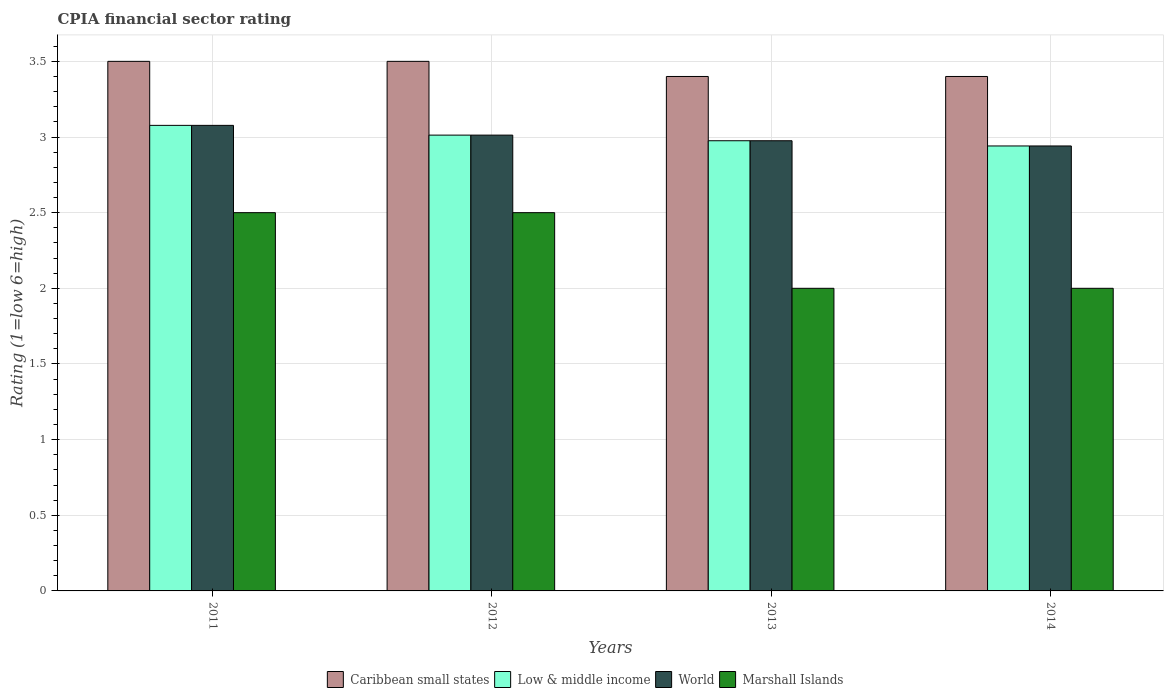How many groups of bars are there?
Offer a terse response. 4. Are the number of bars on each tick of the X-axis equal?
Provide a succinct answer. Yes. What is the label of the 3rd group of bars from the left?
Your response must be concise. 2013. In how many cases, is the number of bars for a given year not equal to the number of legend labels?
Your response must be concise. 0. Across all years, what is the maximum CPIA rating in Marshall Islands?
Your answer should be compact. 2.5. In which year was the CPIA rating in Low & middle income maximum?
Provide a succinct answer. 2011. What is the total CPIA rating in Caribbean small states in the graph?
Your answer should be very brief. 13.8. What is the difference between the CPIA rating in World in 2011 and that in 2014?
Keep it short and to the point. 0.14. What is the difference between the CPIA rating in Low & middle income in 2012 and the CPIA rating in World in 2013?
Your answer should be very brief. 0.04. What is the average CPIA rating in Marshall Islands per year?
Offer a terse response. 2.25. In the year 2011, what is the difference between the CPIA rating in Caribbean small states and CPIA rating in World?
Offer a very short reply. 0.42. What is the ratio of the CPIA rating in Low & middle income in 2012 to that in 2013?
Give a very brief answer. 1.01. Is the difference between the CPIA rating in Caribbean small states in 2011 and 2013 greater than the difference between the CPIA rating in World in 2011 and 2013?
Keep it short and to the point. No. What is the difference between the highest and the lowest CPIA rating in World?
Provide a short and direct response. 0.14. Is the sum of the CPIA rating in Caribbean small states in 2013 and 2014 greater than the maximum CPIA rating in World across all years?
Your response must be concise. Yes. What does the 4th bar from the left in 2014 represents?
Keep it short and to the point. Marshall Islands. How many bars are there?
Keep it short and to the point. 16. Are all the bars in the graph horizontal?
Give a very brief answer. No. How many years are there in the graph?
Offer a very short reply. 4. What is the difference between two consecutive major ticks on the Y-axis?
Keep it short and to the point. 0.5. Are the values on the major ticks of Y-axis written in scientific E-notation?
Ensure brevity in your answer.  No. Does the graph contain any zero values?
Your answer should be very brief. No. Does the graph contain grids?
Provide a short and direct response. Yes. Where does the legend appear in the graph?
Provide a short and direct response. Bottom center. What is the title of the graph?
Your answer should be very brief. CPIA financial sector rating. What is the label or title of the X-axis?
Your answer should be very brief. Years. What is the Rating (1=low 6=high) in Caribbean small states in 2011?
Make the answer very short. 3.5. What is the Rating (1=low 6=high) in Low & middle income in 2011?
Offer a terse response. 3.08. What is the Rating (1=low 6=high) in World in 2011?
Provide a succinct answer. 3.08. What is the Rating (1=low 6=high) of Caribbean small states in 2012?
Keep it short and to the point. 3.5. What is the Rating (1=low 6=high) of Low & middle income in 2012?
Provide a succinct answer. 3.01. What is the Rating (1=low 6=high) in World in 2012?
Provide a short and direct response. 3.01. What is the Rating (1=low 6=high) of Marshall Islands in 2012?
Provide a short and direct response. 2.5. What is the Rating (1=low 6=high) in Caribbean small states in 2013?
Your answer should be very brief. 3.4. What is the Rating (1=low 6=high) in Low & middle income in 2013?
Provide a short and direct response. 2.98. What is the Rating (1=low 6=high) of World in 2013?
Your answer should be compact. 2.98. What is the Rating (1=low 6=high) of Marshall Islands in 2013?
Your response must be concise. 2. What is the Rating (1=low 6=high) of Caribbean small states in 2014?
Offer a very short reply. 3.4. What is the Rating (1=low 6=high) in Low & middle income in 2014?
Keep it short and to the point. 2.94. What is the Rating (1=low 6=high) in World in 2014?
Your response must be concise. 2.94. Across all years, what is the maximum Rating (1=low 6=high) in Caribbean small states?
Your answer should be very brief. 3.5. Across all years, what is the maximum Rating (1=low 6=high) of Low & middle income?
Keep it short and to the point. 3.08. Across all years, what is the maximum Rating (1=low 6=high) of World?
Your answer should be very brief. 3.08. Across all years, what is the maximum Rating (1=low 6=high) of Marshall Islands?
Offer a terse response. 2.5. Across all years, what is the minimum Rating (1=low 6=high) in Caribbean small states?
Offer a terse response. 3.4. Across all years, what is the minimum Rating (1=low 6=high) in Low & middle income?
Offer a terse response. 2.94. Across all years, what is the minimum Rating (1=low 6=high) in World?
Keep it short and to the point. 2.94. What is the total Rating (1=low 6=high) in Low & middle income in the graph?
Give a very brief answer. 12.01. What is the total Rating (1=low 6=high) in World in the graph?
Your answer should be very brief. 12.01. What is the difference between the Rating (1=low 6=high) in Caribbean small states in 2011 and that in 2012?
Your answer should be very brief. 0. What is the difference between the Rating (1=low 6=high) of Low & middle income in 2011 and that in 2012?
Provide a succinct answer. 0.06. What is the difference between the Rating (1=low 6=high) of World in 2011 and that in 2012?
Your answer should be compact. 0.06. What is the difference between the Rating (1=low 6=high) in Low & middle income in 2011 and that in 2013?
Your response must be concise. 0.1. What is the difference between the Rating (1=low 6=high) in World in 2011 and that in 2013?
Provide a succinct answer. 0.1. What is the difference between the Rating (1=low 6=high) of Low & middle income in 2011 and that in 2014?
Provide a short and direct response. 0.14. What is the difference between the Rating (1=low 6=high) in World in 2011 and that in 2014?
Make the answer very short. 0.14. What is the difference between the Rating (1=low 6=high) in Marshall Islands in 2011 and that in 2014?
Keep it short and to the point. 0.5. What is the difference between the Rating (1=low 6=high) in Low & middle income in 2012 and that in 2013?
Provide a short and direct response. 0.04. What is the difference between the Rating (1=low 6=high) in World in 2012 and that in 2013?
Your response must be concise. 0.04. What is the difference between the Rating (1=low 6=high) in Low & middle income in 2012 and that in 2014?
Your answer should be very brief. 0.07. What is the difference between the Rating (1=low 6=high) of World in 2012 and that in 2014?
Your answer should be compact. 0.07. What is the difference between the Rating (1=low 6=high) of Marshall Islands in 2012 and that in 2014?
Keep it short and to the point. 0.5. What is the difference between the Rating (1=low 6=high) in Caribbean small states in 2013 and that in 2014?
Give a very brief answer. 0. What is the difference between the Rating (1=low 6=high) in Low & middle income in 2013 and that in 2014?
Your answer should be very brief. 0.03. What is the difference between the Rating (1=low 6=high) of World in 2013 and that in 2014?
Offer a terse response. 0.03. What is the difference between the Rating (1=low 6=high) of Caribbean small states in 2011 and the Rating (1=low 6=high) of Low & middle income in 2012?
Your response must be concise. 0.49. What is the difference between the Rating (1=low 6=high) of Caribbean small states in 2011 and the Rating (1=low 6=high) of World in 2012?
Provide a short and direct response. 0.49. What is the difference between the Rating (1=low 6=high) of Caribbean small states in 2011 and the Rating (1=low 6=high) of Marshall Islands in 2012?
Your response must be concise. 1. What is the difference between the Rating (1=low 6=high) of Low & middle income in 2011 and the Rating (1=low 6=high) of World in 2012?
Offer a very short reply. 0.06. What is the difference between the Rating (1=low 6=high) in Low & middle income in 2011 and the Rating (1=low 6=high) in Marshall Islands in 2012?
Make the answer very short. 0.58. What is the difference between the Rating (1=low 6=high) of World in 2011 and the Rating (1=low 6=high) of Marshall Islands in 2012?
Offer a terse response. 0.58. What is the difference between the Rating (1=low 6=high) of Caribbean small states in 2011 and the Rating (1=low 6=high) of Low & middle income in 2013?
Offer a very short reply. 0.52. What is the difference between the Rating (1=low 6=high) of Caribbean small states in 2011 and the Rating (1=low 6=high) of World in 2013?
Offer a terse response. 0.52. What is the difference between the Rating (1=low 6=high) in Low & middle income in 2011 and the Rating (1=low 6=high) in World in 2013?
Make the answer very short. 0.1. What is the difference between the Rating (1=low 6=high) in Low & middle income in 2011 and the Rating (1=low 6=high) in Marshall Islands in 2013?
Provide a succinct answer. 1.08. What is the difference between the Rating (1=low 6=high) in Caribbean small states in 2011 and the Rating (1=low 6=high) in Low & middle income in 2014?
Your answer should be compact. 0.56. What is the difference between the Rating (1=low 6=high) in Caribbean small states in 2011 and the Rating (1=low 6=high) in World in 2014?
Provide a succinct answer. 0.56. What is the difference between the Rating (1=low 6=high) in Low & middle income in 2011 and the Rating (1=low 6=high) in World in 2014?
Offer a very short reply. 0.14. What is the difference between the Rating (1=low 6=high) of Low & middle income in 2011 and the Rating (1=low 6=high) of Marshall Islands in 2014?
Offer a terse response. 1.08. What is the difference between the Rating (1=low 6=high) of Caribbean small states in 2012 and the Rating (1=low 6=high) of Low & middle income in 2013?
Your answer should be very brief. 0.52. What is the difference between the Rating (1=low 6=high) in Caribbean small states in 2012 and the Rating (1=low 6=high) in World in 2013?
Make the answer very short. 0.52. What is the difference between the Rating (1=low 6=high) of Caribbean small states in 2012 and the Rating (1=low 6=high) of Marshall Islands in 2013?
Make the answer very short. 1.5. What is the difference between the Rating (1=low 6=high) in Low & middle income in 2012 and the Rating (1=low 6=high) in World in 2013?
Offer a terse response. 0.04. What is the difference between the Rating (1=low 6=high) of Low & middle income in 2012 and the Rating (1=low 6=high) of Marshall Islands in 2013?
Make the answer very short. 1.01. What is the difference between the Rating (1=low 6=high) of World in 2012 and the Rating (1=low 6=high) of Marshall Islands in 2013?
Your answer should be compact. 1.01. What is the difference between the Rating (1=low 6=high) of Caribbean small states in 2012 and the Rating (1=low 6=high) of Low & middle income in 2014?
Make the answer very short. 0.56. What is the difference between the Rating (1=low 6=high) of Caribbean small states in 2012 and the Rating (1=low 6=high) of World in 2014?
Make the answer very short. 0.56. What is the difference between the Rating (1=low 6=high) in Low & middle income in 2012 and the Rating (1=low 6=high) in World in 2014?
Provide a succinct answer. 0.07. What is the difference between the Rating (1=low 6=high) of Low & middle income in 2012 and the Rating (1=low 6=high) of Marshall Islands in 2014?
Your answer should be very brief. 1.01. What is the difference between the Rating (1=low 6=high) of World in 2012 and the Rating (1=low 6=high) of Marshall Islands in 2014?
Your response must be concise. 1.01. What is the difference between the Rating (1=low 6=high) in Caribbean small states in 2013 and the Rating (1=low 6=high) in Low & middle income in 2014?
Offer a terse response. 0.46. What is the difference between the Rating (1=low 6=high) in Caribbean small states in 2013 and the Rating (1=low 6=high) in World in 2014?
Your response must be concise. 0.46. What is the difference between the Rating (1=low 6=high) in Caribbean small states in 2013 and the Rating (1=low 6=high) in Marshall Islands in 2014?
Make the answer very short. 1.4. What is the difference between the Rating (1=low 6=high) of Low & middle income in 2013 and the Rating (1=low 6=high) of World in 2014?
Provide a succinct answer. 0.03. What is the difference between the Rating (1=low 6=high) in Low & middle income in 2013 and the Rating (1=low 6=high) in Marshall Islands in 2014?
Your answer should be very brief. 0.98. What is the difference between the Rating (1=low 6=high) of World in 2013 and the Rating (1=low 6=high) of Marshall Islands in 2014?
Your answer should be very brief. 0.98. What is the average Rating (1=low 6=high) of Caribbean small states per year?
Keep it short and to the point. 3.45. What is the average Rating (1=low 6=high) of Low & middle income per year?
Ensure brevity in your answer.  3. What is the average Rating (1=low 6=high) of World per year?
Make the answer very short. 3. What is the average Rating (1=low 6=high) of Marshall Islands per year?
Ensure brevity in your answer.  2.25. In the year 2011, what is the difference between the Rating (1=low 6=high) of Caribbean small states and Rating (1=low 6=high) of Low & middle income?
Offer a terse response. 0.42. In the year 2011, what is the difference between the Rating (1=low 6=high) of Caribbean small states and Rating (1=low 6=high) of World?
Give a very brief answer. 0.42. In the year 2011, what is the difference between the Rating (1=low 6=high) in Low & middle income and Rating (1=low 6=high) in World?
Make the answer very short. 0. In the year 2011, what is the difference between the Rating (1=low 6=high) of Low & middle income and Rating (1=low 6=high) of Marshall Islands?
Keep it short and to the point. 0.58. In the year 2011, what is the difference between the Rating (1=low 6=high) in World and Rating (1=low 6=high) in Marshall Islands?
Provide a succinct answer. 0.58. In the year 2012, what is the difference between the Rating (1=low 6=high) of Caribbean small states and Rating (1=low 6=high) of Low & middle income?
Make the answer very short. 0.49. In the year 2012, what is the difference between the Rating (1=low 6=high) of Caribbean small states and Rating (1=low 6=high) of World?
Ensure brevity in your answer.  0.49. In the year 2012, what is the difference between the Rating (1=low 6=high) in Caribbean small states and Rating (1=low 6=high) in Marshall Islands?
Your response must be concise. 1. In the year 2012, what is the difference between the Rating (1=low 6=high) in Low & middle income and Rating (1=low 6=high) in Marshall Islands?
Your answer should be compact. 0.51. In the year 2012, what is the difference between the Rating (1=low 6=high) of World and Rating (1=low 6=high) of Marshall Islands?
Your answer should be compact. 0.51. In the year 2013, what is the difference between the Rating (1=low 6=high) of Caribbean small states and Rating (1=low 6=high) of Low & middle income?
Provide a short and direct response. 0.42. In the year 2013, what is the difference between the Rating (1=low 6=high) in Caribbean small states and Rating (1=low 6=high) in World?
Offer a very short reply. 0.42. In the year 2013, what is the difference between the Rating (1=low 6=high) of Low & middle income and Rating (1=low 6=high) of Marshall Islands?
Your answer should be compact. 0.98. In the year 2013, what is the difference between the Rating (1=low 6=high) of World and Rating (1=low 6=high) of Marshall Islands?
Make the answer very short. 0.98. In the year 2014, what is the difference between the Rating (1=low 6=high) of Caribbean small states and Rating (1=low 6=high) of Low & middle income?
Provide a succinct answer. 0.46. In the year 2014, what is the difference between the Rating (1=low 6=high) in Caribbean small states and Rating (1=low 6=high) in World?
Your answer should be very brief. 0.46. In the year 2014, what is the difference between the Rating (1=low 6=high) in Caribbean small states and Rating (1=low 6=high) in Marshall Islands?
Give a very brief answer. 1.4. In the year 2014, what is the difference between the Rating (1=low 6=high) of Low & middle income and Rating (1=low 6=high) of World?
Make the answer very short. 0. In the year 2014, what is the difference between the Rating (1=low 6=high) of Low & middle income and Rating (1=low 6=high) of Marshall Islands?
Offer a very short reply. 0.94. In the year 2014, what is the difference between the Rating (1=low 6=high) in World and Rating (1=low 6=high) in Marshall Islands?
Your response must be concise. 0.94. What is the ratio of the Rating (1=low 6=high) in Low & middle income in 2011 to that in 2012?
Your response must be concise. 1.02. What is the ratio of the Rating (1=low 6=high) of World in 2011 to that in 2012?
Your response must be concise. 1.02. What is the ratio of the Rating (1=low 6=high) of Marshall Islands in 2011 to that in 2012?
Provide a succinct answer. 1. What is the ratio of the Rating (1=low 6=high) of Caribbean small states in 2011 to that in 2013?
Offer a terse response. 1.03. What is the ratio of the Rating (1=low 6=high) of Low & middle income in 2011 to that in 2013?
Give a very brief answer. 1.03. What is the ratio of the Rating (1=low 6=high) of World in 2011 to that in 2013?
Keep it short and to the point. 1.03. What is the ratio of the Rating (1=low 6=high) in Caribbean small states in 2011 to that in 2014?
Keep it short and to the point. 1.03. What is the ratio of the Rating (1=low 6=high) in Low & middle income in 2011 to that in 2014?
Your response must be concise. 1.05. What is the ratio of the Rating (1=low 6=high) of World in 2011 to that in 2014?
Your answer should be compact. 1.05. What is the ratio of the Rating (1=low 6=high) of Caribbean small states in 2012 to that in 2013?
Give a very brief answer. 1.03. What is the ratio of the Rating (1=low 6=high) of Low & middle income in 2012 to that in 2013?
Give a very brief answer. 1.01. What is the ratio of the Rating (1=low 6=high) of World in 2012 to that in 2013?
Ensure brevity in your answer.  1.01. What is the ratio of the Rating (1=low 6=high) of Caribbean small states in 2012 to that in 2014?
Provide a short and direct response. 1.03. What is the ratio of the Rating (1=low 6=high) of Low & middle income in 2012 to that in 2014?
Provide a short and direct response. 1.02. What is the ratio of the Rating (1=low 6=high) in World in 2012 to that in 2014?
Keep it short and to the point. 1.02. What is the ratio of the Rating (1=low 6=high) of Marshall Islands in 2012 to that in 2014?
Ensure brevity in your answer.  1.25. What is the ratio of the Rating (1=low 6=high) in Low & middle income in 2013 to that in 2014?
Offer a very short reply. 1.01. What is the ratio of the Rating (1=low 6=high) in World in 2013 to that in 2014?
Your answer should be compact. 1.01. What is the difference between the highest and the second highest Rating (1=low 6=high) of Caribbean small states?
Your answer should be very brief. 0. What is the difference between the highest and the second highest Rating (1=low 6=high) of Low & middle income?
Give a very brief answer. 0.06. What is the difference between the highest and the second highest Rating (1=low 6=high) in World?
Provide a succinct answer. 0.06. What is the difference between the highest and the second highest Rating (1=low 6=high) of Marshall Islands?
Your response must be concise. 0. What is the difference between the highest and the lowest Rating (1=low 6=high) of Caribbean small states?
Ensure brevity in your answer.  0.1. What is the difference between the highest and the lowest Rating (1=low 6=high) in Low & middle income?
Offer a terse response. 0.14. What is the difference between the highest and the lowest Rating (1=low 6=high) of World?
Keep it short and to the point. 0.14. What is the difference between the highest and the lowest Rating (1=low 6=high) of Marshall Islands?
Your response must be concise. 0.5. 